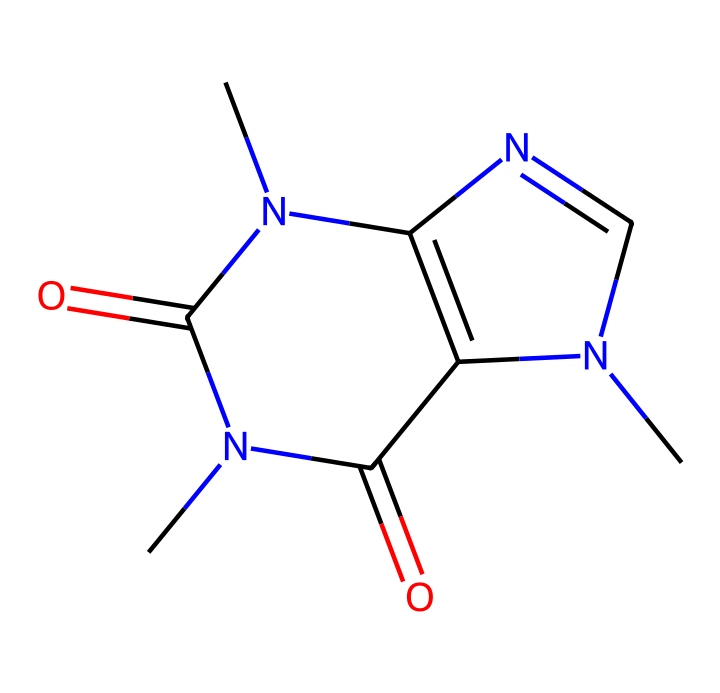What is the molecular formula of caffeine? To derive the molecular formula, count the number of each type of atom in the SMILES representation. The structure indicates there are 8 carbon (C) atoms, 10 hydrogen (H) atoms, 4 nitrogen (N) atoms, and 2 oxygen (O) atoms. Therefore, the molecular formula is C8H10N4O2.
Answer: C8H10N4O2 How many nitrogen atoms are present in caffeine? By analyzing the SMILES notation, we identify four nitrogen (N) atoms within the structure. Thus, there are 4 nitrogen atoms.
Answer: 4 What type of chemical compound is caffeine? The structure displays properties typical of an alkaloid due to the presence of nitrogen and it being a naturally occurring compound in plants, particularly coffee.
Answer: alkaloid What functional groups are present in caffeine? By examining the structure, we can identify amine groups (from the nitrogen atoms) and carbonyl groups (from the carbon-oxygen double bonds). The presence of these functional groups indicates caffeine has both amine and carbonyl functionalities.
Answer: amine and carbonyl How many rings are present in the structure of caffeine? The SMILES representation shows that there are two fused rings in the structure. By observing the connections and confirming the cyclic nature, we can conclude that caffeine contains two rings.
Answer: 2 What is the significance of the carbonyl groups in caffeine? Carbonyl groups are important in modifying the reactivity of a molecule, influencing its interactions and biological activities, which in caffeine contributes to its stimulant properties.
Answer: modifies reactivity Which structural feature of caffeine contributes to its water solubility? Caffeine has polar functional groups such as nitrogen and carbonyls that interact with water molecules, enhancing its solubility in water. This is critical for its physiological effects.
Answer: polar functional groups 